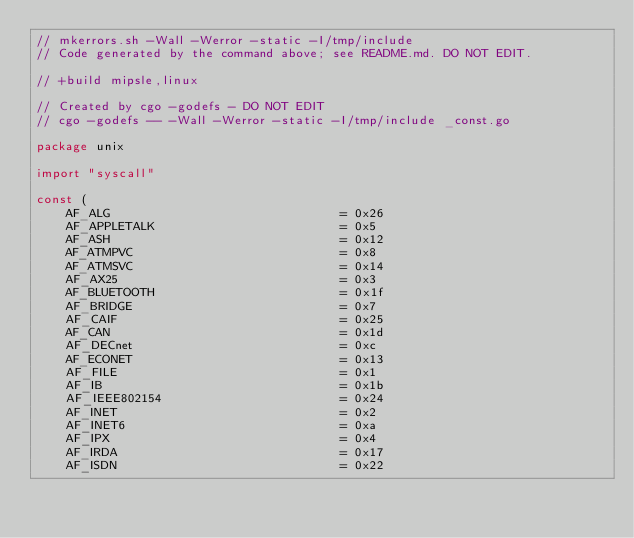Convert code to text. <code><loc_0><loc_0><loc_500><loc_500><_Go_>// mkerrors.sh -Wall -Werror -static -I/tmp/include
// Code generated by the command above; see README.md. DO NOT EDIT.

// +build mipsle,linux

// Created by cgo -godefs - DO NOT EDIT
// cgo -godefs -- -Wall -Werror -static -I/tmp/include _const.go

package unix

import "syscall"

const (
	AF_ALG                               = 0x26
	AF_APPLETALK                         = 0x5
	AF_ASH                               = 0x12
	AF_ATMPVC                            = 0x8
	AF_ATMSVC                            = 0x14
	AF_AX25                              = 0x3
	AF_BLUETOOTH                         = 0x1f
	AF_BRIDGE                            = 0x7
	AF_CAIF                              = 0x25
	AF_CAN                               = 0x1d
	AF_DECnet                            = 0xc
	AF_ECONET                            = 0x13
	AF_FILE                              = 0x1
	AF_IB                                = 0x1b
	AF_IEEE802154                        = 0x24
	AF_INET                              = 0x2
	AF_INET6                             = 0xa
	AF_IPX                               = 0x4
	AF_IRDA                              = 0x17
	AF_ISDN                              = 0x22</code> 